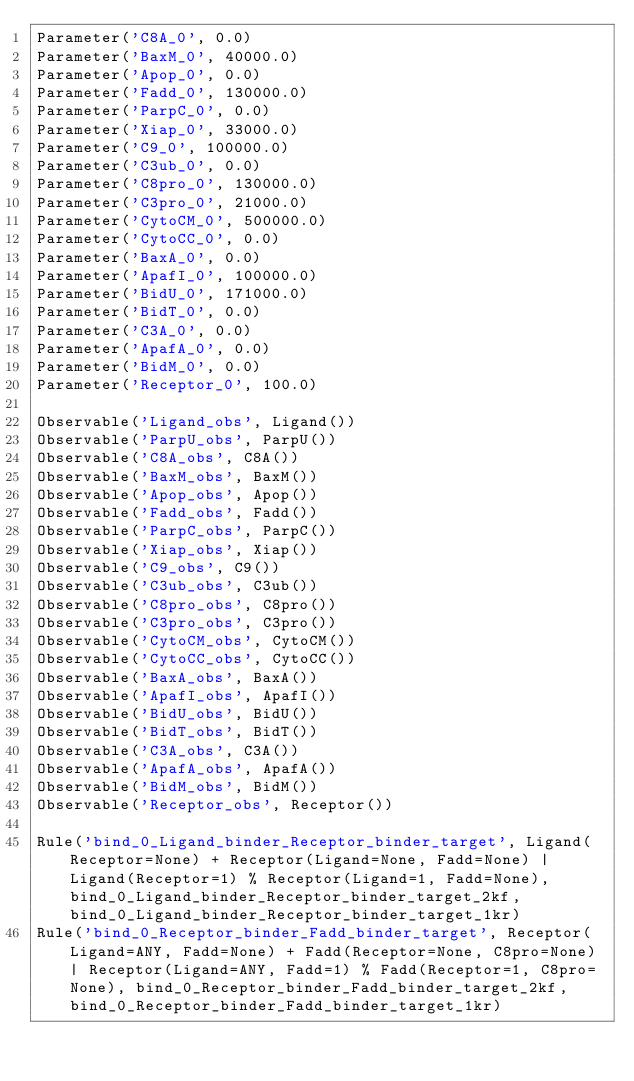<code> <loc_0><loc_0><loc_500><loc_500><_Python_>Parameter('C8A_0', 0.0)
Parameter('BaxM_0', 40000.0)
Parameter('Apop_0', 0.0)
Parameter('Fadd_0', 130000.0)
Parameter('ParpC_0', 0.0)
Parameter('Xiap_0', 33000.0)
Parameter('C9_0', 100000.0)
Parameter('C3ub_0', 0.0)
Parameter('C8pro_0', 130000.0)
Parameter('C3pro_0', 21000.0)
Parameter('CytoCM_0', 500000.0)
Parameter('CytoCC_0', 0.0)
Parameter('BaxA_0', 0.0)
Parameter('ApafI_0', 100000.0)
Parameter('BidU_0', 171000.0)
Parameter('BidT_0', 0.0)
Parameter('C3A_0', 0.0)
Parameter('ApafA_0', 0.0)
Parameter('BidM_0', 0.0)
Parameter('Receptor_0', 100.0)

Observable('Ligand_obs', Ligand())
Observable('ParpU_obs', ParpU())
Observable('C8A_obs', C8A())
Observable('BaxM_obs', BaxM())
Observable('Apop_obs', Apop())
Observable('Fadd_obs', Fadd())
Observable('ParpC_obs', ParpC())
Observable('Xiap_obs', Xiap())
Observable('C9_obs', C9())
Observable('C3ub_obs', C3ub())
Observable('C8pro_obs', C8pro())
Observable('C3pro_obs', C3pro())
Observable('CytoCM_obs', CytoCM())
Observable('CytoCC_obs', CytoCC())
Observable('BaxA_obs', BaxA())
Observable('ApafI_obs', ApafI())
Observable('BidU_obs', BidU())
Observable('BidT_obs', BidT())
Observable('C3A_obs', C3A())
Observable('ApafA_obs', ApafA())
Observable('BidM_obs', BidM())
Observable('Receptor_obs', Receptor())

Rule('bind_0_Ligand_binder_Receptor_binder_target', Ligand(Receptor=None) + Receptor(Ligand=None, Fadd=None) | Ligand(Receptor=1) % Receptor(Ligand=1, Fadd=None), bind_0_Ligand_binder_Receptor_binder_target_2kf, bind_0_Ligand_binder_Receptor_binder_target_1kr)
Rule('bind_0_Receptor_binder_Fadd_binder_target', Receptor(Ligand=ANY, Fadd=None) + Fadd(Receptor=None, C8pro=None) | Receptor(Ligand=ANY, Fadd=1) % Fadd(Receptor=1, C8pro=None), bind_0_Receptor_binder_Fadd_binder_target_2kf, bind_0_Receptor_binder_Fadd_binder_target_1kr)</code> 